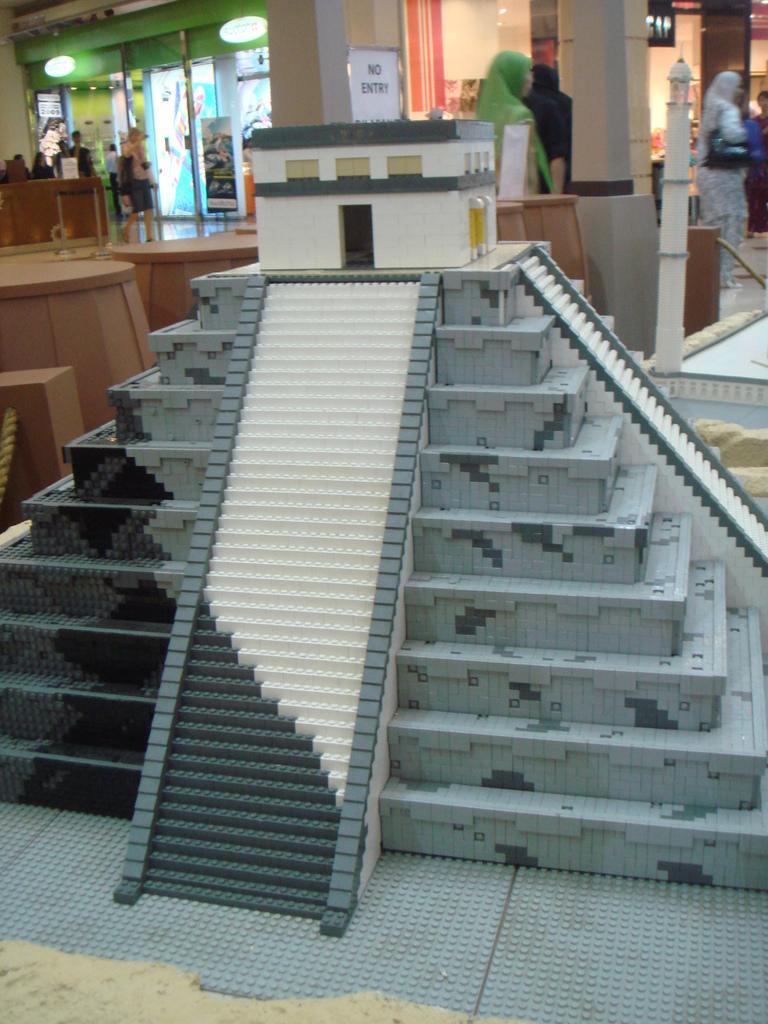Describe this image in one or two sentences. In the image we can see there is a pyramid statue and behind there are other people standing. There is a sign board on which it's written "No Entry". 